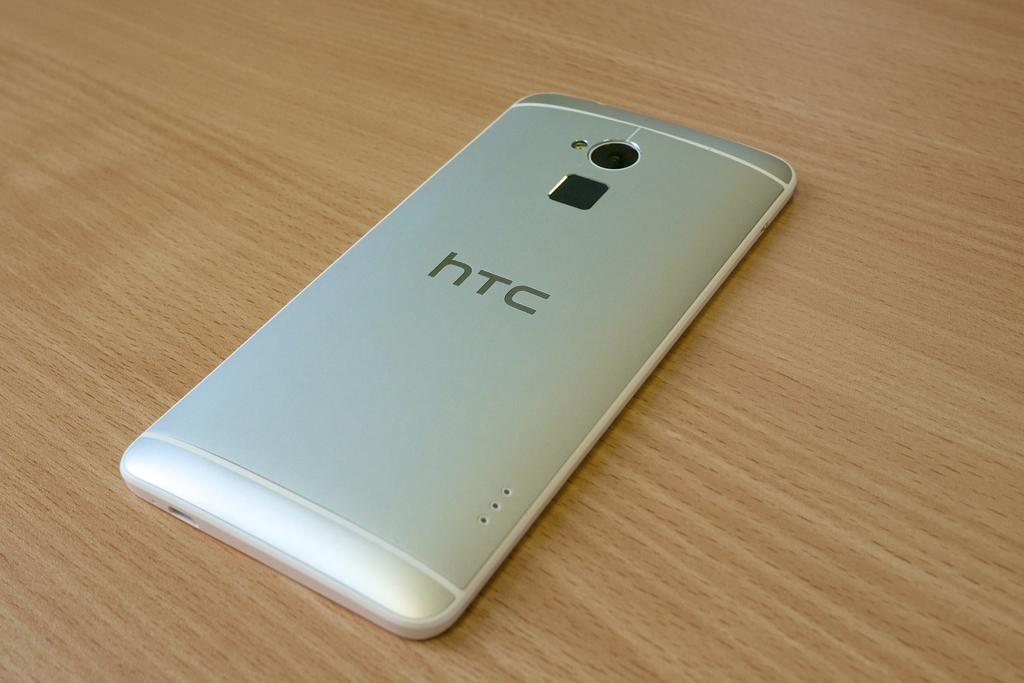<image>
Describe the image concisely. Silver HTC cellphone face down on a wooden table. 